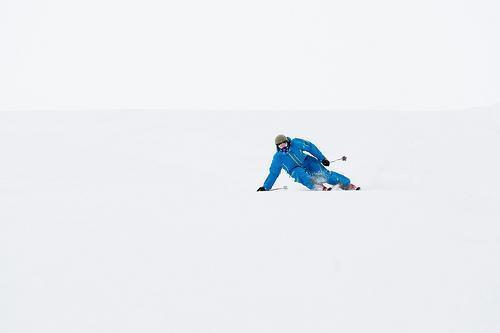How many people are shown?
Give a very brief answer. 1. 